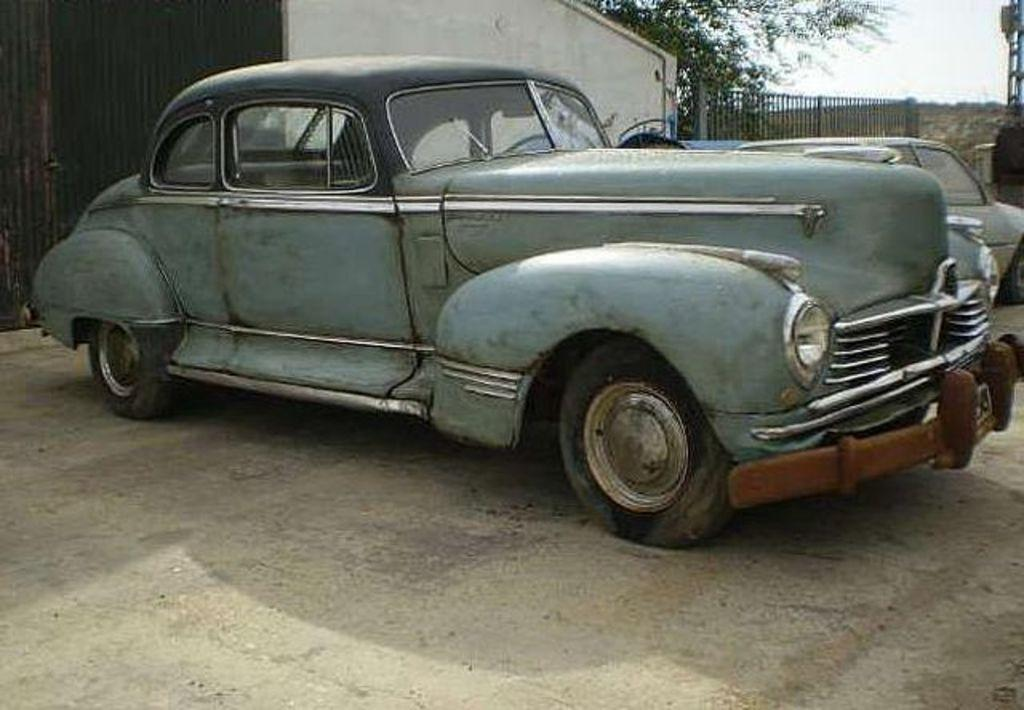What can be seen on the road in the image? There are vehicles on the road in the image. What is visible in the background of the image? There is a wall, railing, trees, and the sky visible in the background of the image. What type of crook can be seen trying to surprise someone with a calculator in the image? There is no crook, surprise, or calculator present in the image. 